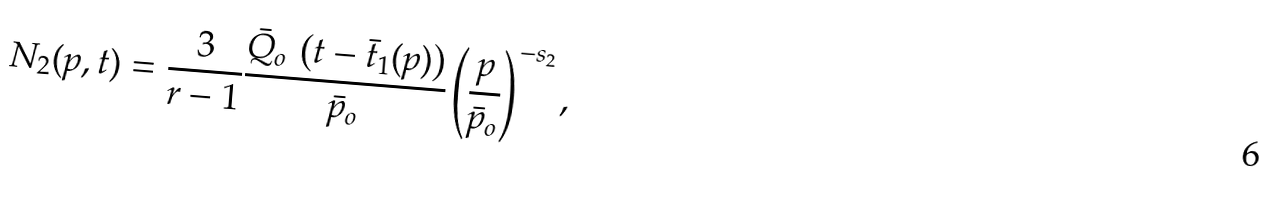Convert formula to latex. <formula><loc_0><loc_0><loc_500><loc_500>N _ { 2 } ( p , t ) = \frac { 3 } { r - 1 } \frac { \bar { Q } _ { o } \, \left ( t - \bar { t } _ { 1 } ( p ) \right ) } { \bar { p } _ { o } } \left ( \frac { p } { \bar { p } _ { o } } \right ) ^ { - s _ { 2 } } ,</formula> 